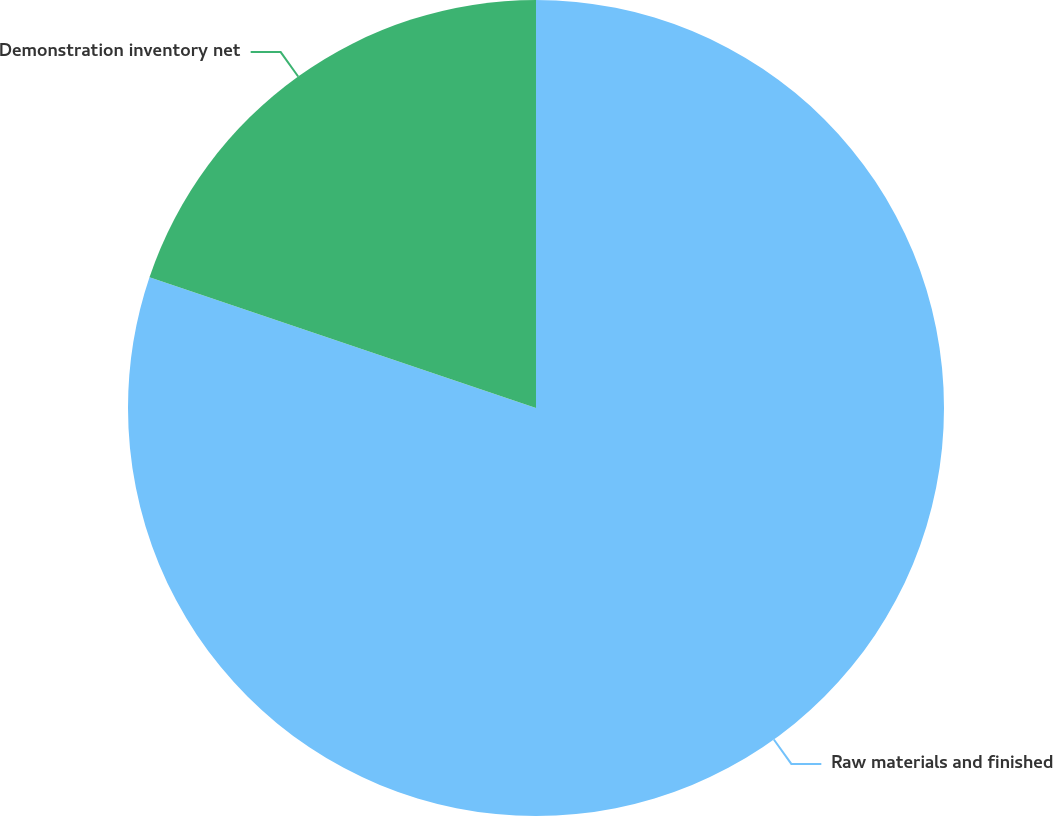Convert chart to OTSL. <chart><loc_0><loc_0><loc_500><loc_500><pie_chart><fcel>Raw materials and finished<fcel>Demonstration inventory net<nl><fcel>80.19%<fcel>19.81%<nl></chart> 